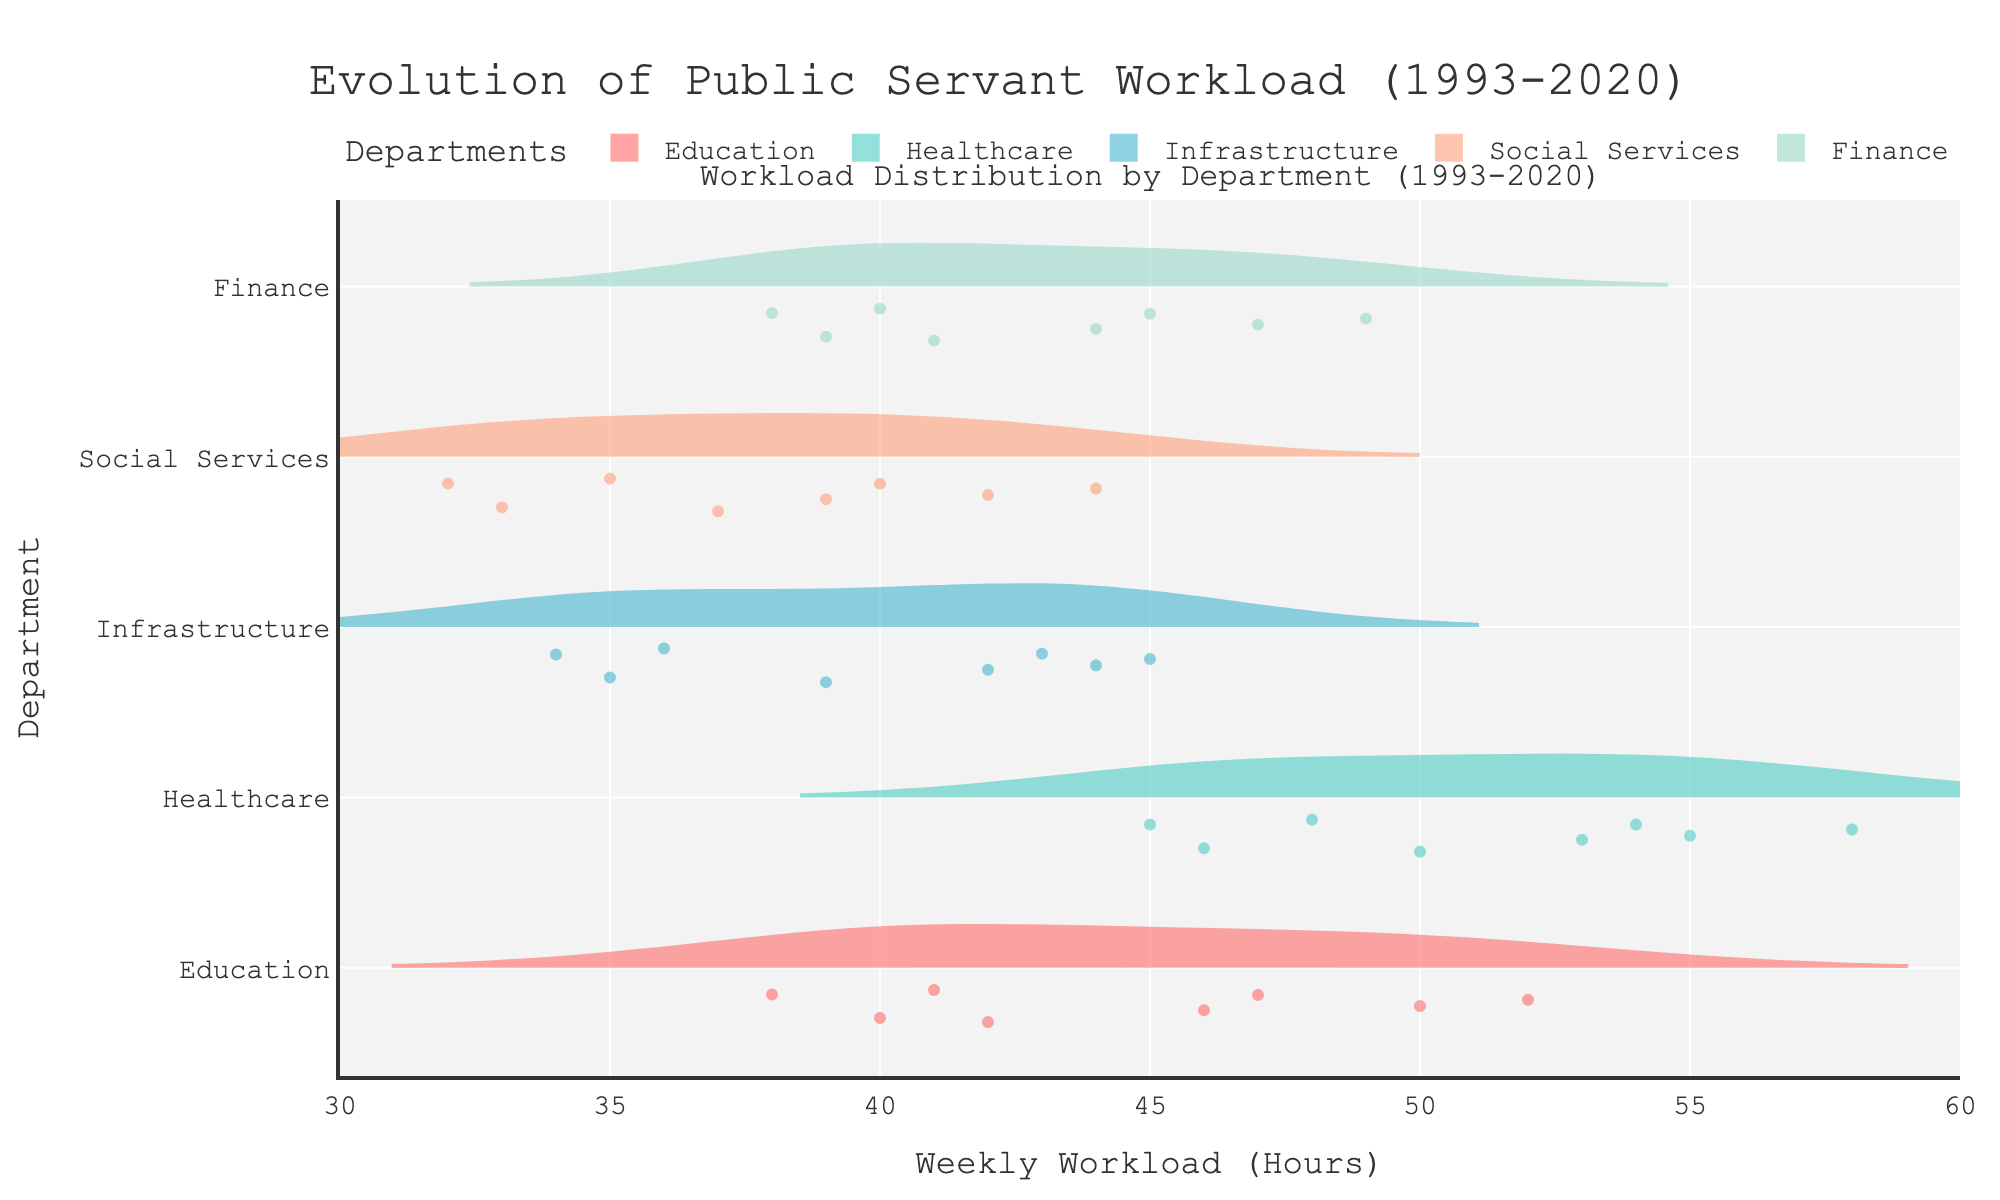What is the title of the figure? The title is displayed at the top of the figure and reads "Evolution of Public Servant Workload (1993-2020)."
Answer: Evolution of Public Servant Workload (1993-2020) What does the x-axis represent? The x-axis is labeled "Weekly Workload (Hours)" and measures the number of hours worked weekly by public servants.
Answer: Weekly Workload (Hours) Which department has the highest median workload in 2020? The violin plots show a distribution for each department. By looking at the median markers (typically horizontal lines inside the violins), Healthcare shows the highest median workload.
Answer: Healthcare Which department shows the smallest increase in workload from 1993 to 2020? By comparing the left and right extents of the violins for each department, Infrastructure shows the smallest increase from 35 in 1993 to 45 in 2020, an increase of 10 hours.
Answer: Infrastructure How does the workload for the Finance department trend over time? The violin plot for the Finance department shows a general increase in the median workload from approximately 38 hours in 1993 to 49 hours in 2020.
Answer: Generally increasing What is the overall range of workload hours observed in the Education department? The Education department's violin plot spans from around 38 hours to 52 hours when observing the extreme points of the distribution.
Answer: 38 to 52 hours Between 1993 and 2020, which department has the most consistent workload? Consistency is reflected by the width and overlap of the violins; Social Services shows a relatively narrower and consistent distribution compared to others.
Answer: Social Services Which two departments have the most overlap in their workload distributions? Looking at the violin plots' overlapping areas, Education and Finance show significant overlap in their workload distributions around the 40-50 hours range.
Answer: Education and Finance What is the trend for Healthcare department workloads from 1993 to 2020? Examining the violin plot for Healthcare, it consistently shows an upward trend from around 45 hours in 1993 to about 58 hours in 2020.
Answer: Increasing Is there any department where the workload has decreased over time? By observing the violin plots, none of the departments show a downward trend; all have increased workloads over the years.
Answer: No 